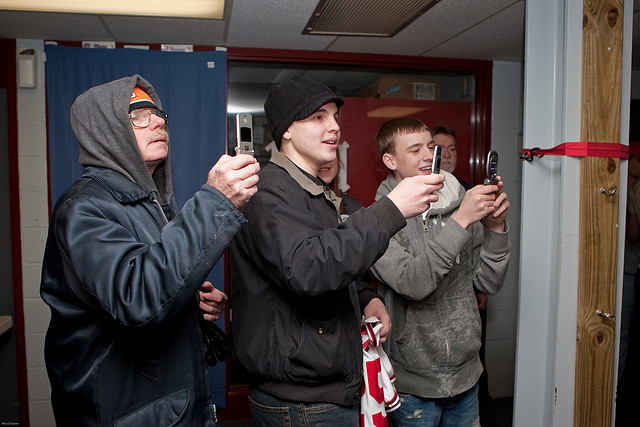<image>What does the website say? The website content is not visible in the image. What does the website say? The website is not visible in the image. 